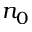<formula> <loc_0><loc_0><loc_500><loc_500>n _ { 0 }</formula> 